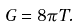<formula> <loc_0><loc_0><loc_500><loc_500>G = 8 \pi T .</formula> 